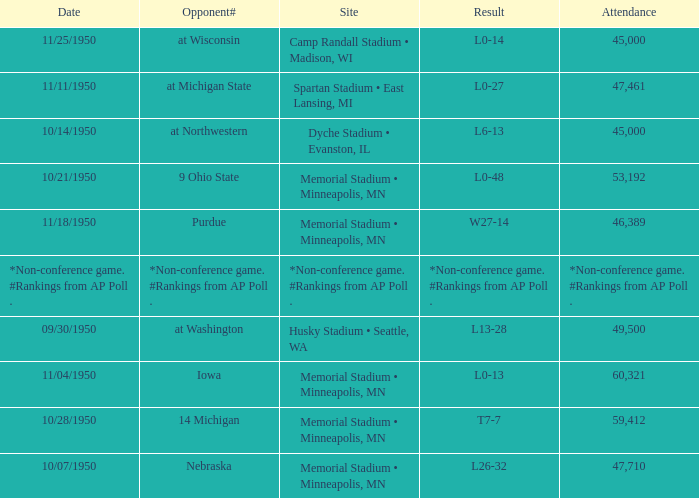What is the Date when the result is *non-conference game. #rankings from ap poll .? *Non-conference game. #Rankings from AP Poll . 